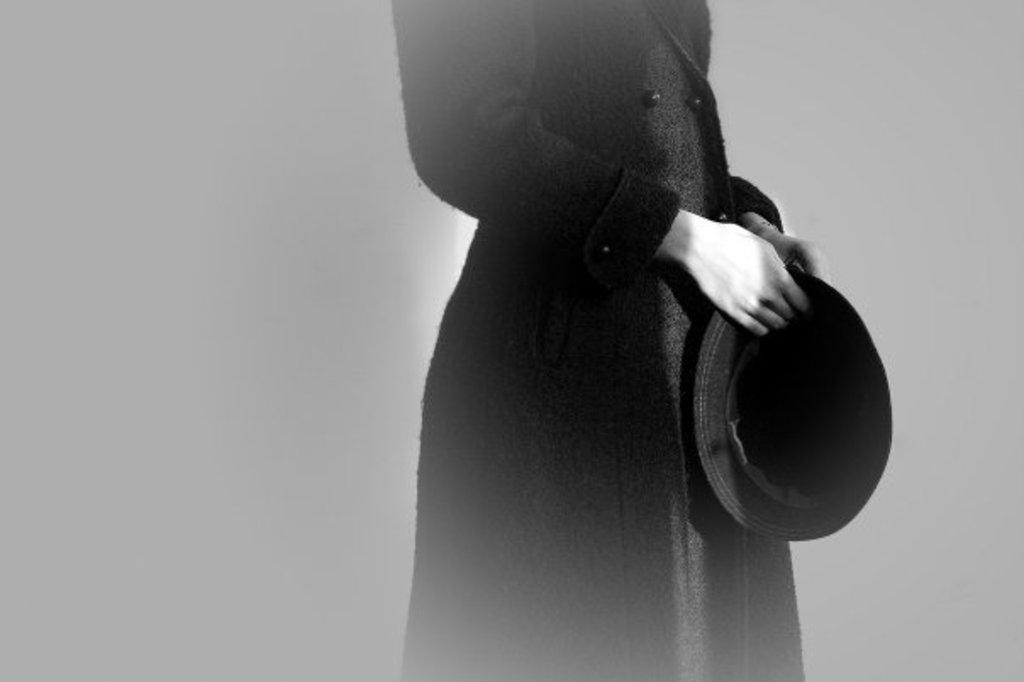Describe this image in one or two sentences. In this picture I can observe a person standing, wearing black color coat. I can observe a hat in the hands of the person. This is a black and white picture. 